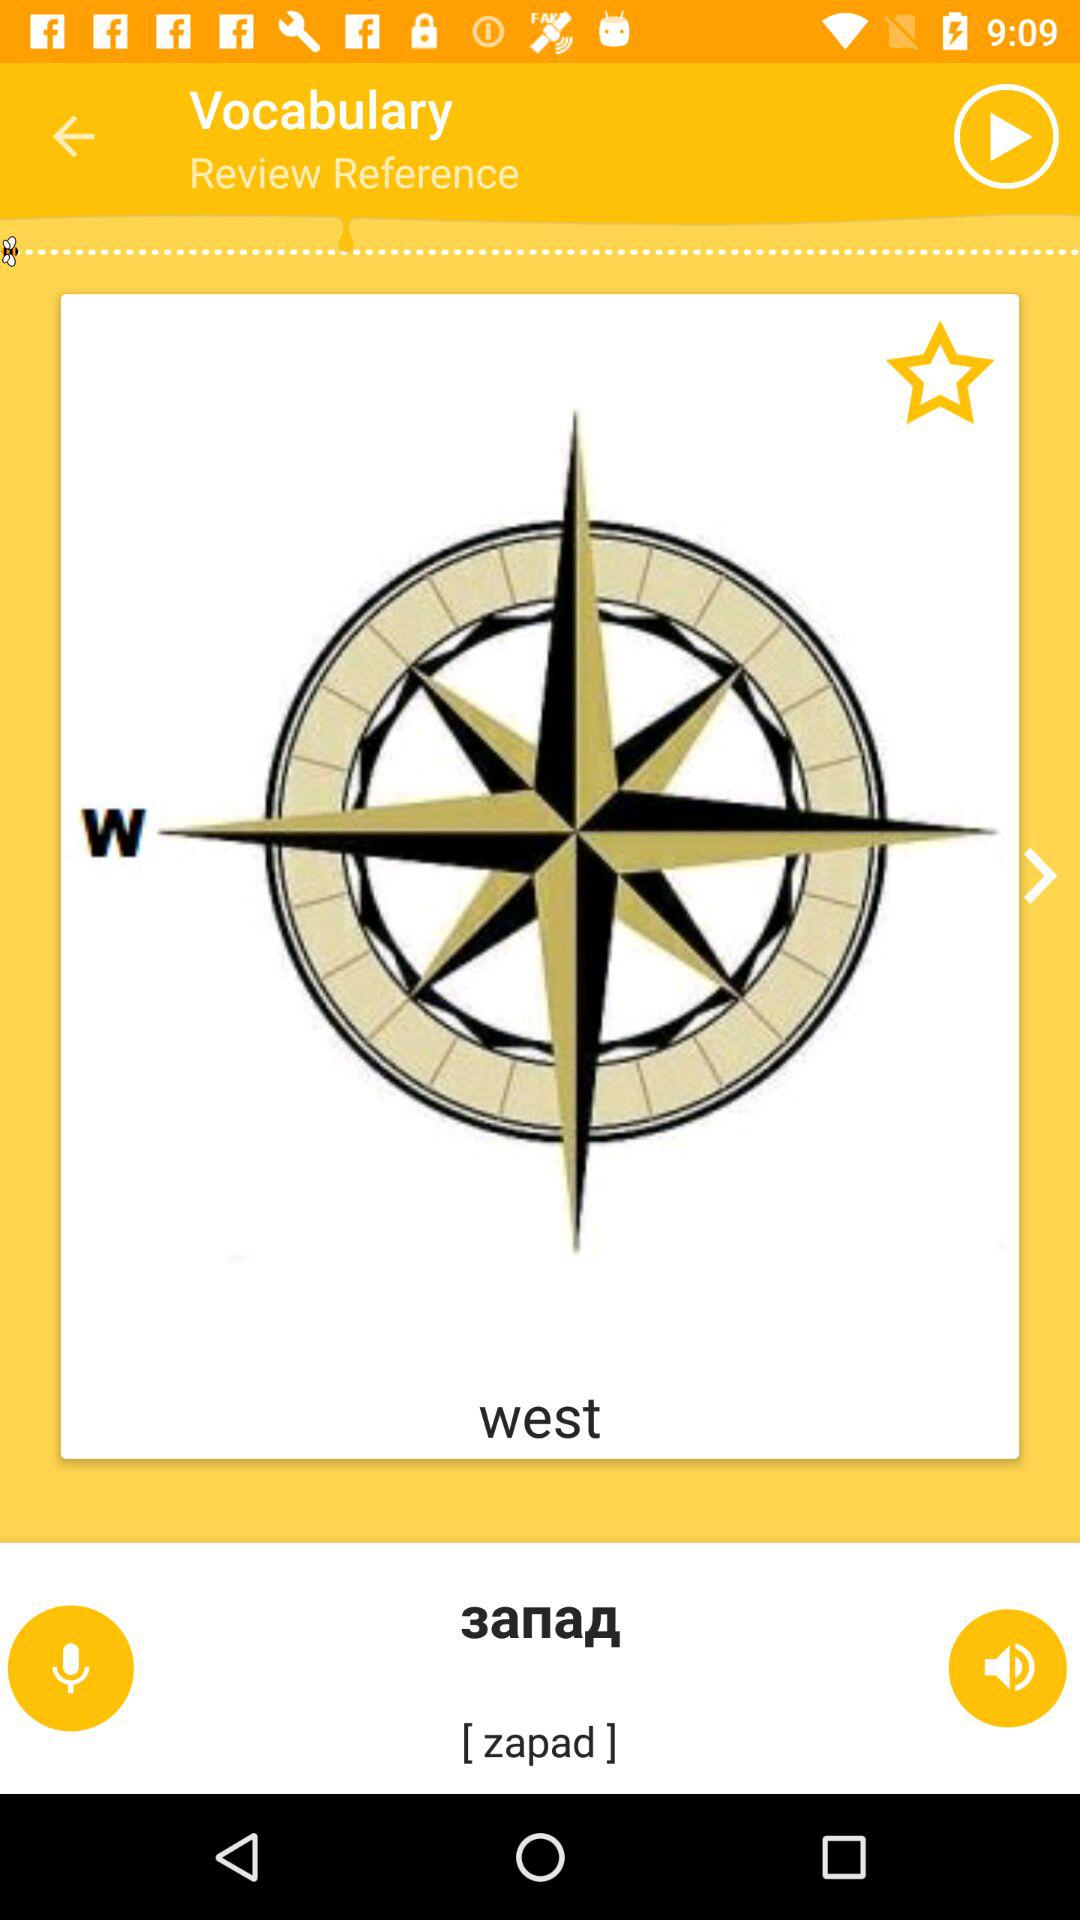Which language is the word translated into?
When the provided information is insufficient, respond with <no answer>. <no answer> 